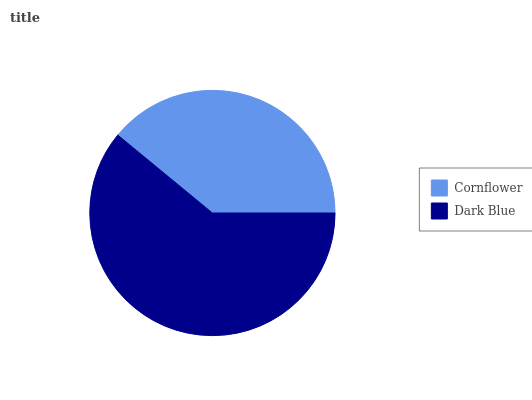Is Cornflower the minimum?
Answer yes or no. Yes. Is Dark Blue the maximum?
Answer yes or no. Yes. Is Dark Blue the minimum?
Answer yes or no. No. Is Dark Blue greater than Cornflower?
Answer yes or no. Yes. Is Cornflower less than Dark Blue?
Answer yes or no. Yes. Is Cornflower greater than Dark Blue?
Answer yes or no. No. Is Dark Blue less than Cornflower?
Answer yes or no. No. Is Dark Blue the high median?
Answer yes or no. Yes. Is Cornflower the low median?
Answer yes or no. Yes. Is Cornflower the high median?
Answer yes or no. No. Is Dark Blue the low median?
Answer yes or no. No. 